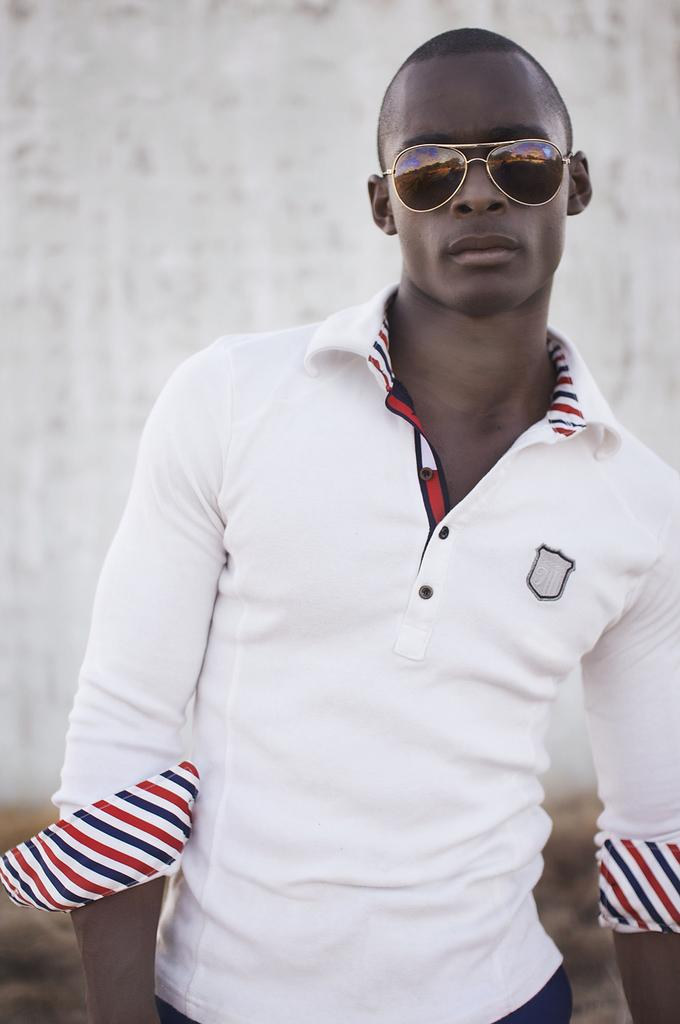What is the main subject of the image? There is a man standing in the image. What is the man wearing on his face? The man is wearing goggles. What type of clothing is the man wearing on his upper body? The man is wearing a white T-shirt. What can be seen in the background of the image? There is a wall in the background of the image. What is the color of the wall in the image? The wall is white in color. What type of bone can be seen in the man's hand in the image? There is no bone visible in the man's hand in the image. What kind of drum is the man playing in the image? There is no drum present in the image; the man is wearing goggles and a white T-shirt. 